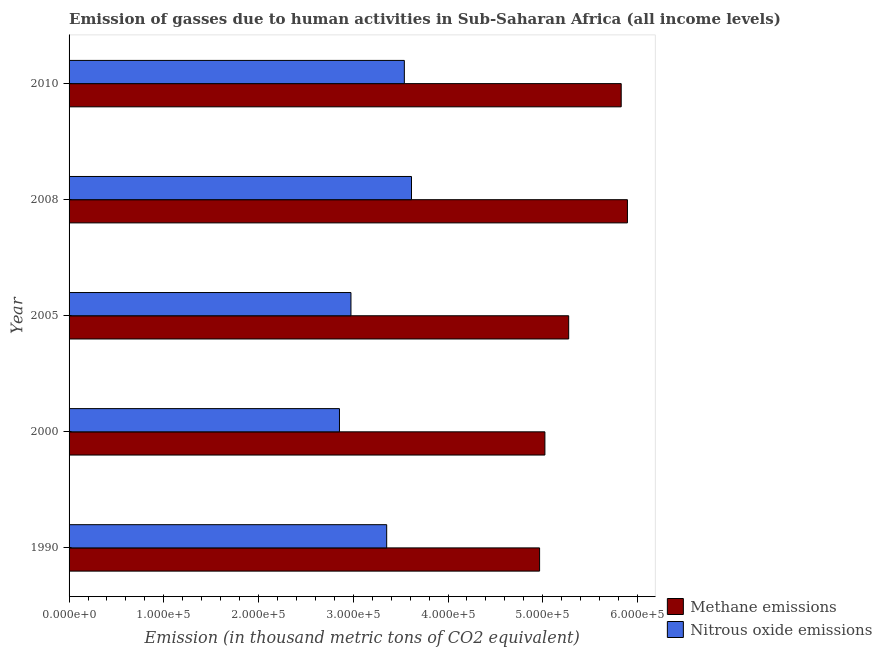How many different coloured bars are there?
Offer a very short reply. 2. How many groups of bars are there?
Your response must be concise. 5. Are the number of bars on each tick of the Y-axis equal?
Ensure brevity in your answer.  Yes. How many bars are there on the 3rd tick from the bottom?
Keep it short and to the point. 2. In how many cases, is the number of bars for a given year not equal to the number of legend labels?
Your answer should be very brief. 0. What is the amount of methane emissions in 2010?
Your response must be concise. 5.83e+05. Across all years, what is the maximum amount of methane emissions?
Give a very brief answer. 5.89e+05. Across all years, what is the minimum amount of nitrous oxide emissions?
Ensure brevity in your answer.  2.85e+05. What is the total amount of nitrous oxide emissions in the graph?
Your answer should be very brief. 1.63e+06. What is the difference between the amount of nitrous oxide emissions in 2000 and that in 2005?
Ensure brevity in your answer.  -1.21e+04. What is the difference between the amount of methane emissions in 2005 and the amount of nitrous oxide emissions in 2010?
Your answer should be very brief. 1.73e+05. What is the average amount of nitrous oxide emissions per year?
Your response must be concise. 3.27e+05. In the year 2000, what is the difference between the amount of nitrous oxide emissions and amount of methane emissions?
Offer a terse response. -2.17e+05. What is the ratio of the amount of nitrous oxide emissions in 2000 to that in 2010?
Keep it short and to the point. 0.81. Is the amount of methane emissions in 1990 less than that in 2010?
Keep it short and to the point. Yes. Is the difference between the amount of nitrous oxide emissions in 2005 and 2010 greater than the difference between the amount of methane emissions in 2005 and 2010?
Make the answer very short. No. What is the difference between the highest and the second highest amount of nitrous oxide emissions?
Give a very brief answer. 7568.3. What is the difference between the highest and the lowest amount of nitrous oxide emissions?
Keep it short and to the point. 7.60e+04. In how many years, is the amount of methane emissions greater than the average amount of methane emissions taken over all years?
Give a very brief answer. 2. What does the 1st bar from the top in 2005 represents?
Offer a terse response. Nitrous oxide emissions. What does the 1st bar from the bottom in 2008 represents?
Provide a short and direct response. Methane emissions. How many years are there in the graph?
Offer a terse response. 5. Are the values on the major ticks of X-axis written in scientific E-notation?
Give a very brief answer. Yes. Does the graph contain any zero values?
Give a very brief answer. No. Where does the legend appear in the graph?
Provide a short and direct response. Bottom right. How are the legend labels stacked?
Offer a terse response. Vertical. What is the title of the graph?
Offer a very short reply. Emission of gasses due to human activities in Sub-Saharan Africa (all income levels). Does "Foreign Liabilities" appear as one of the legend labels in the graph?
Provide a succinct answer. No. What is the label or title of the X-axis?
Make the answer very short. Emission (in thousand metric tons of CO2 equivalent). What is the label or title of the Y-axis?
Ensure brevity in your answer.  Year. What is the Emission (in thousand metric tons of CO2 equivalent) in Methane emissions in 1990?
Ensure brevity in your answer.  4.97e+05. What is the Emission (in thousand metric tons of CO2 equivalent) in Nitrous oxide emissions in 1990?
Your answer should be very brief. 3.35e+05. What is the Emission (in thousand metric tons of CO2 equivalent) in Methane emissions in 2000?
Your response must be concise. 5.02e+05. What is the Emission (in thousand metric tons of CO2 equivalent) of Nitrous oxide emissions in 2000?
Offer a very short reply. 2.85e+05. What is the Emission (in thousand metric tons of CO2 equivalent) of Methane emissions in 2005?
Offer a terse response. 5.27e+05. What is the Emission (in thousand metric tons of CO2 equivalent) of Nitrous oxide emissions in 2005?
Make the answer very short. 2.98e+05. What is the Emission (in thousand metric tons of CO2 equivalent) in Methane emissions in 2008?
Your answer should be very brief. 5.89e+05. What is the Emission (in thousand metric tons of CO2 equivalent) of Nitrous oxide emissions in 2008?
Keep it short and to the point. 3.61e+05. What is the Emission (in thousand metric tons of CO2 equivalent) in Methane emissions in 2010?
Ensure brevity in your answer.  5.83e+05. What is the Emission (in thousand metric tons of CO2 equivalent) in Nitrous oxide emissions in 2010?
Your answer should be very brief. 3.54e+05. Across all years, what is the maximum Emission (in thousand metric tons of CO2 equivalent) of Methane emissions?
Provide a succinct answer. 5.89e+05. Across all years, what is the maximum Emission (in thousand metric tons of CO2 equivalent) in Nitrous oxide emissions?
Provide a short and direct response. 3.61e+05. Across all years, what is the minimum Emission (in thousand metric tons of CO2 equivalent) of Methane emissions?
Your answer should be very brief. 4.97e+05. Across all years, what is the minimum Emission (in thousand metric tons of CO2 equivalent) in Nitrous oxide emissions?
Offer a very short reply. 2.85e+05. What is the total Emission (in thousand metric tons of CO2 equivalent) of Methane emissions in the graph?
Make the answer very short. 2.70e+06. What is the total Emission (in thousand metric tons of CO2 equivalent) in Nitrous oxide emissions in the graph?
Ensure brevity in your answer.  1.63e+06. What is the difference between the Emission (in thousand metric tons of CO2 equivalent) in Methane emissions in 1990 and that in 2000?
Offer a terse response. -5608.2. What is the difference between the Emission (in thousand metric tons of CO2 equivalent) in Nitrous oxide emissions in 1990 and that in 2000?
Ensure brevity in your answer.  4.98e+04. What is the difference between the Emission (in thousand metric tons of CO2 equivalent) of Methane emissions in 1990 and that in 2005?
Keep it short and to the point. -3.07e+04. What is the difference between the Emission (in thousand metric tons of CO2 equivalent) in Nitrous oxide emissions in 1990 and that in 2005?
Provide a succinct answer. 3.77e+04. What is the difference between the Emission (in thousand metric tons of CO2 equivalent) of Methane emissions in 1990 and that in 2008?
Ensure brevity in your answer.  -9.27e+04. What is the difference between the Emission (in thousand metric tons of CO2 equivalent) in Nitrous oxide emissions in 1990 and that in 2008?
Offer a terse response. -2.62e+04. What is the difference between the Emission (in thousand metric tons of CO2 equivalent) in Methane emissions in 1990 and that in 2010?
Provide a short and direct response. -8.61e+04. What is the difference between the Emission (in thousand metric tons of CO2 equivalent) in Nitrous oxide emissions in 1990 and that in 2010?
Your response must be concise. -1.86e+04. What is the difference between the Emission (in thousand metric tons of CO2 equivalent) in Methane emissions in 2000 and that in 2005?
Your response must be concise. -2.51e+04. What is the difference between the Emission (in thousand metric tons of CO2 equivalent) of Nitrous oxide emissions in 2000 and that in 2005?
Your answer should be compact. -1.21e+04. What is the difference between the Emission (in thousand metric tons of CO2 equivalent) of Methane emissions in 2000 and that in 2008?
Ensure brevity in your answer.  -8.71e+04. What is the difference between the Emission (in thousand metric tons of CO2 equivalent) in Nitrous oxide emissions in 2000 and that in 2008?
Ensure brevity in your answer.  -7.60e+04. What is the difference between the Emission (in thousand metric tons of CO2 equivalent) in Methane emissions in 2000 and that in 2010?
Make the answer very short. -8.05e+04. What is the difference between the Emission (in thousand metric tons of CO2 equivalent) in Nitrous oxide emissions in 2000 and that in 2010?
Make the answer very short. -6.85e+04. What is the difference between the Emission (in thousand metric tons of CO2 equivalent) of Methane emissions in 2005 and that in 2008?
Offer a terse response. -6.20e+04. What is the difference between the Emission (in thousand metric tons of CO2 equivalent) in Nitrous oxide emissions in 2005 and that in 2008?
Offer a very short reply. -6.39e+04. What is the difference between the Emission (in thousand metric tons of CO2 equivalent) of Methane emissions in 2005 and that in 2010?
Offer a terse response. -5.54e+04. What is the difference between the Emission (in thousand metric tons of CO2 equivalent) in Nitrous oxide emissions in 2005 and that in 2010?
Provide a short and direct response. -5.63e+04. What is the difference between the Emission (in thousand metric tons of CO2 equivalent) of Methane emissions in 2008 and that in 2010?
Ensure brevity in your answer.  6576.5. What is the difference between the Emission (in thousand metric tons of CO2 equivalent) in Nitrous oxide emissions in 2008 and that in 2010?
Provide a succinct answer. 7568.3. What is the difference between the Emission (in thousand metric tons of CO2 equivalent) of Methane emissions in 1990 and the Emission (in thousand metric tons of CO2 equivalent) of Nitrous oxide emissions in 2000?
Offer a very short reply. 2.11e+05. What is the difference between the Emission (in thousand metric tons of CO2 equivalent) of Methane emissions in 1990 and the Emission (in thousand metric tons of CO2 equivalent) of Nitrous oxide emissions in 2005?
Provide a succinct answer. 1.99e+05. What is the difference between the Emission (in thousand metric tons of CO2 equivalent) of Methane emissions in 1990 and the Emission (in thousand metric tons of CO2 equivalent) of Nitrous oxide emissions in 2008?
Make the answer very short. 1.35e+05. What is the difference between the Emission (in thousand metric tons of CO2 equivalent) of Methane emissions in 1990 and the Emission (in thousand metric tons of CO2 equivalent) of Nitrous oxide emissions in 2010?
Offer a very short reply. 1.43e+05. What is the difference between the Emission (in thousand metric tons of CO2 equivalent) of Methane emissions in 2000 and the Emission (in thousand metric tons of CO2 equivalent) of Nitrous oxide emissions in 2005?
Give a very brief answer. 2.05e+05. What is the difference between the Emission (in thousand metric tons of CO2 equivalent) in Methane emissions in 2000 and the Emission (in thousand metric tons of CO2 equivalent) in Nitrous oxide emissions in 2008?
Keep it short and to the point. 1.41e+05. What is the difference between the Emission (in thousand metric tons of CO2 equivalent) in Methane emissions in 2000 and the Emission (in thousand metric tons of CO2 equivalent) in Nitrous oxide emissions in 2010?
Make the answer very short. 1.48e+05. What is the difference between the Emission (in thousand metric tons of CO2 equivalent) in Methane emissions in 2005 and the Emission (in thousand metric tons of CO2 equivalent) in Nitrous oxide emissions in 2008?
Give a very brief answer. 1.66e+05. What is the difference between the Emission (in thousand metric tons of CO2 equivalent) in Methane emissions in 2005 and the Emission (in thousand metric tons of CO2 equivalent) in Nitrous oxide emissions in 2010?
Provide a short and direct response. 1.73e+05. What is the difference between the Emission (in thousand metric tons of CO2 equivalent) in Methane emissions in 2008 and the Emission (in thousand metric tons of CO2 equivalent) in Nitrous oxide emissions in 2010?
Provide a short and direct response. 2.35e+05. What is the average Emission (in thousand metric tons of CO2 equivalent) of Methane emissions per year?
Provide a short and direct response. 5.40e+05. What is the average Emission (in thousand metric tons of CO2 equivalent) of Nitrous oxide emissions per year?
Keep it short and to the point. 3.27e+05. In the year 1990, what is the difference between the Emission (in thousand metric tons of CO2 equivalent) of Methane emissions and Emission (in thousand metric tons of CO2 equivalent) of Nitrous oxide emissions?
Keep it short and to the point. 1.61e+05. In the year 2000, what is the difference between the Emission (in thousand metric tons of CO2 equivalent) in Methane emissions and Emission (in thousand metric tons of CO2 equivalent) in Nitrous oxide emissions?
Offer a very short reply. 2.17e+05. In the year 2005, what is the difference between the Emission (in thousand metric tons of CO2 equivalent) in Methane emissions and Emission (in thousand metric tons of CO2 equivalent) in Nitrous oxide emissions?
Make the answer very short. 2.30e+05. In the year 2008, what is the difference between the Emission (in thousand metric tons of CO2 equivalent) of Methane emissions and Emission (in thousand metric tons of CO2 equivalent) of Nitrous oxide emissions?
Your answer should be compact. 2.28e+05. In the year 2010, what is the difference between the Emission (in thousand metric tons of CO2 equivalent) in Methane emissions and Emission (in thousand metric tons of CO2 equivalent) in Nitrous oxide emissions?
Make the answer very short. 2.29e+05. What is the ratio of the Emission (in thousand metric tons of CO2 equivalent) of Nitrous oxide emissions in 1990 to that in 2000?
Make the answer very short. 1.17. What is the ratio of the Emission (in thousand metric tons of CO2 equivalent) in Methane emissions in 1990 to that in 2005?
Make the answer very short. 0.94. What is the ratio of the Emission (in thousand metric tons of CO2 equivalent) of Nitrous oxide emissions in 1990 to that in 2005?
Make the answer very short. 1.13. What is the ratio of the Emission (in thousand metric tons of CO2 equivalent) of Methane emissions in 1990 to that in 2008?
Ensure brevity in your answer.  0.84. What is the ratio of the Emission (in thousand metric tons of CO2 equivalent) of Nitrous oxide emissions in 1990 to that in 2008?
Keep it short and to the point. 0.93. What is the ratio of the Emission (in thousand metric tons of CO2 equivalent) of Methane emissions in 1990 to that in 2010?
Provide a short and direct response. 0.85. What is the ratio of the Emission (in thousand metric tons of CO2 equivalent) in Nitrous oxide emissions in 1990 to that in 2010?
Ensure brevity in your answer.  0.95. What is the ratio of the Emission (in thousand metric tons of CO2 equivalent) of Nitrous oxide emissions in 2000 to that in 2005?
Keep it short and to the point. 0.96. What is the ratio of the Emission (in thousand metric tons of CO2 equivalent) of Methane emissions in 2000 to that in 2008?
Keep it short and to the point. 0.85. What is the ratio of the Emission (in thousand metric tons of CO2 equivalent) of Nitrous oxide emissions in 2000 to that in 2008?
Make the answer very short. 0.79. What is the ratio of the Emission (in thousand metric tons of CO2 equivalent) in Methane emissions in 2000 to that in 2010?
Your answer should be very brief. 0.86. What is the ratio of the Emission (in thousand metric tons of CO2 equivalent) in Nitrous oxide emissions in 2000 to that in 2010?
Ensure brevity in your answer.  0.81. What is the ratio of the Emission (in thousand metric tons of CO2 equivalent) of Methane emissions in 2005 to that in 2008?
Ensure brevity in your answer.  0.89. What is the ratio of the Emission (in thousand metric tons of CO2 equivalent) of Nitrous oxide emissions in 2005 to that in 2008?
Ensure brevity in your answer.  0.82. What is the ratio of the Emission (in thousand metric tons of CO2 equivalent) of Methane emissions in 2005 to that in 2010?
Ensure brevity in your answer.  0.9. What is the ratio of the Emission (in thousand metric tons of CO2 equivalent) of Nitrous oxide emissions in 2005 to that in 2010?
Offer a very short reply. 0.84. What is the ratio of the Emission (in thousand metric tons of CO2 equivalent) in Methane emissions in 2008 to that in 2010?
Ensure brevity in your answer.  1.01. What is the ratio of the Emission (in thousand metric tons of CO2 equivalent) of Nitrous oxide emissions in 2008 to that in 2010?
Your response must be concise. 1.02. What is the difference between the highest and the second highest Emission (in thousand metric tons of CO2 equivalent) in Methane emissions?
Give a very brief answer. 6576.5. What is the difference between the highest and the second highest Emission (in thousand metric tons of CO2 equivalent) in Nitrous oxide emissions?
Ensure brevity in your answer.  7568.3. What is the difference between the highest and the lowest Emission (in thousand metric tons of CO2 equivalent) in Methane emissions?
Your answer should be very brief. 9.27e+04. What is the difference between the highest and the lowest Emission (in thousand metric tons of CO2 equivalent) in Nitrous oxide emissions?
Provide a short and direct response. 7.60e+04. 